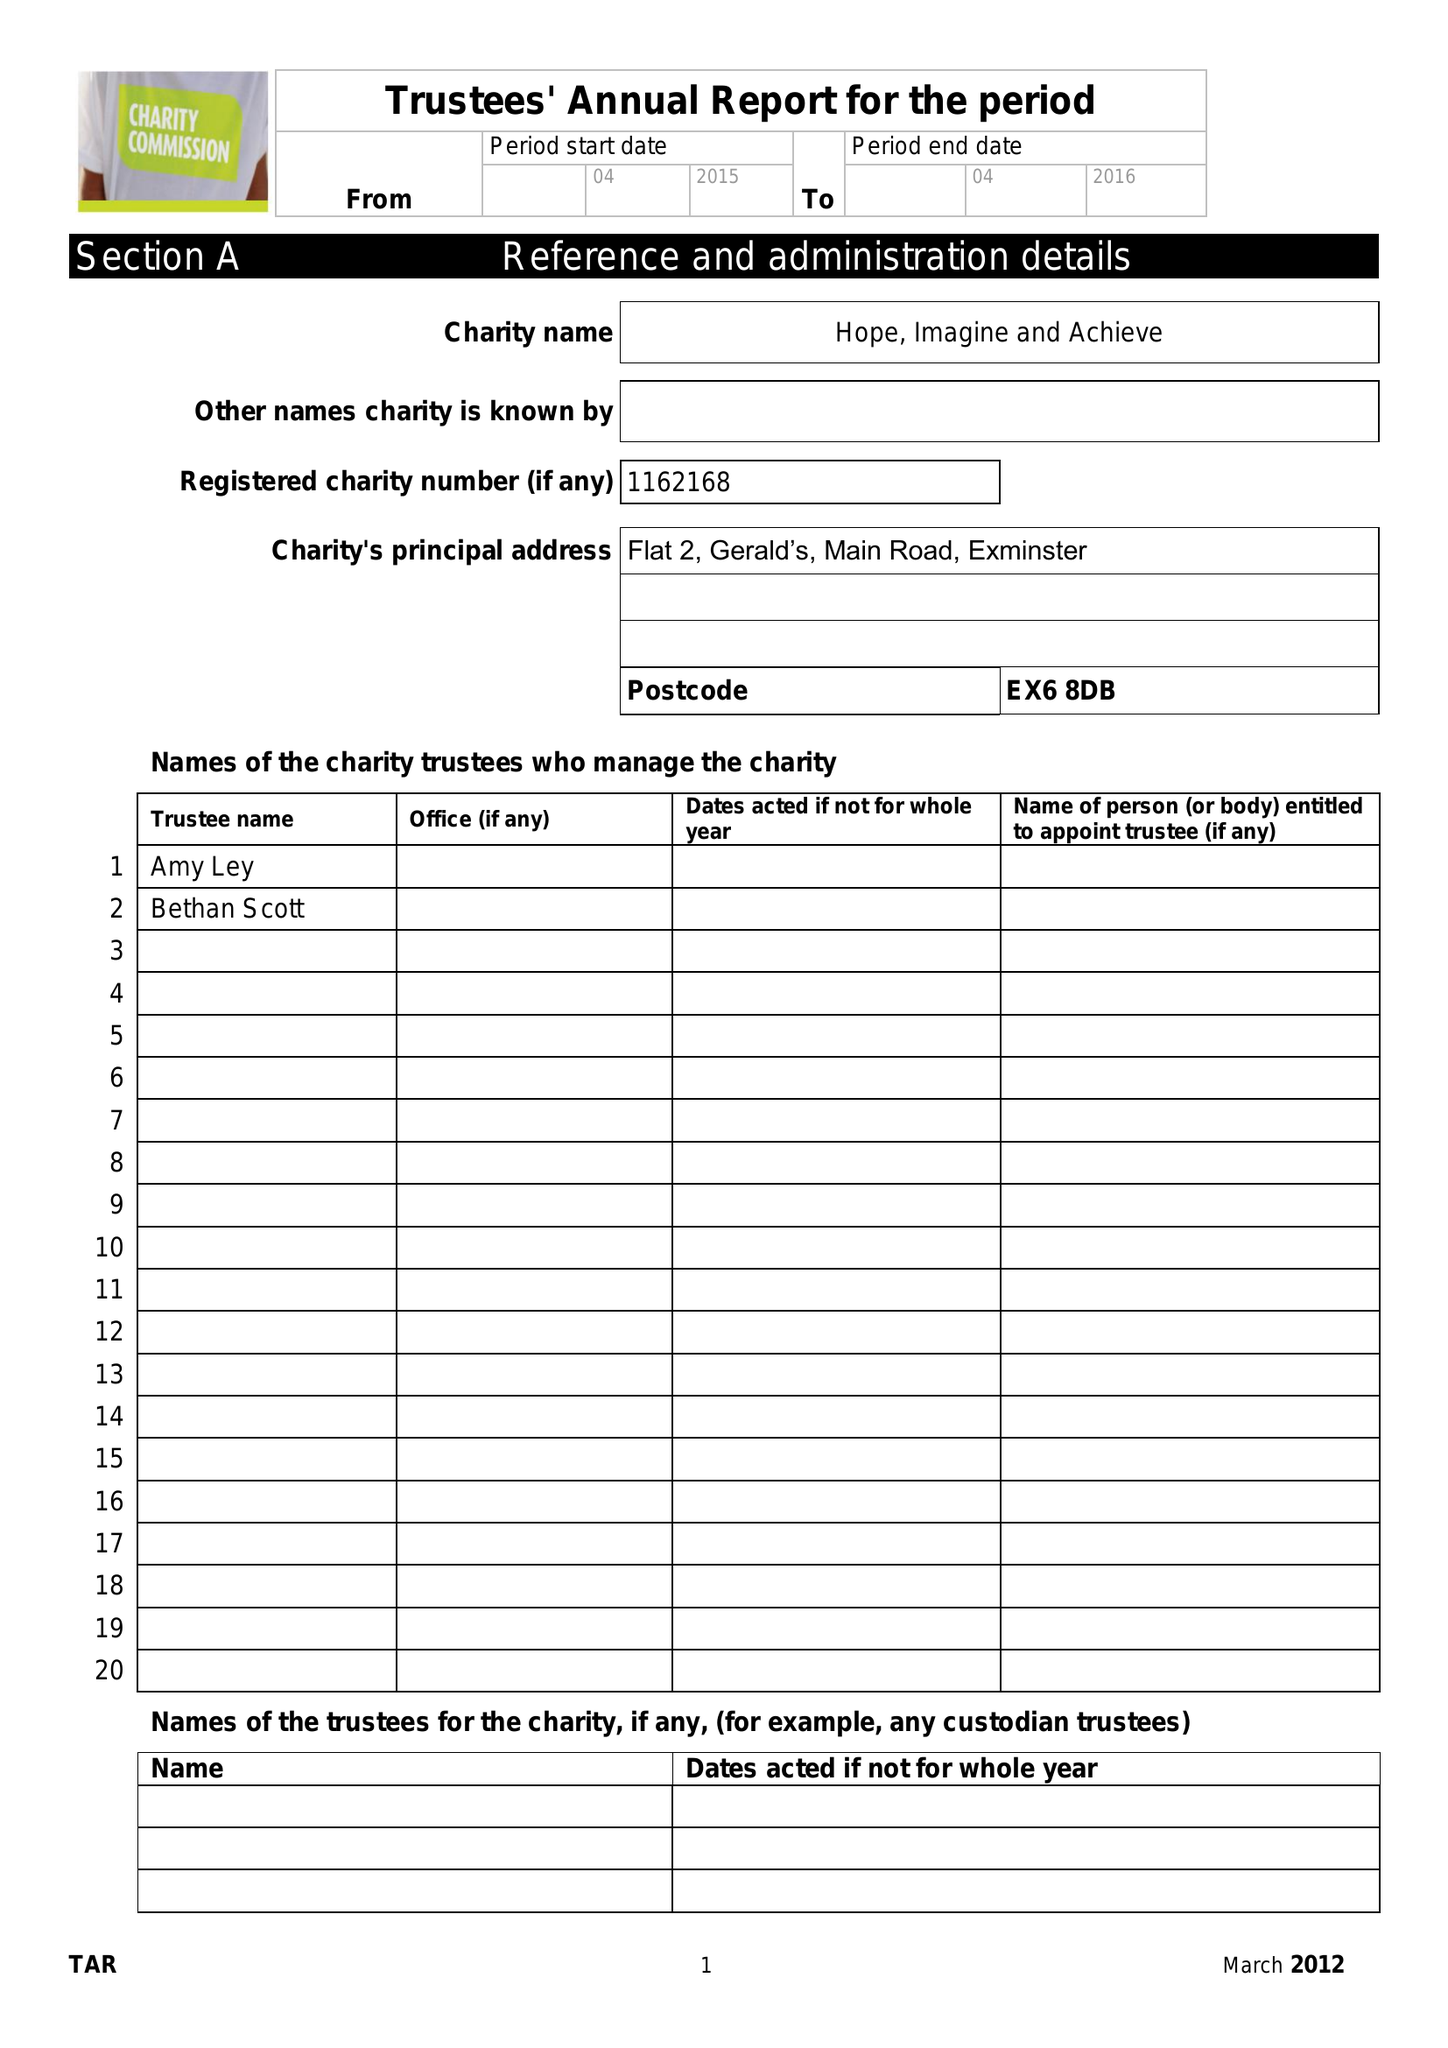What is the value for the address__postcode?
Answer the question using a single word or phrase. EX6 8DB 